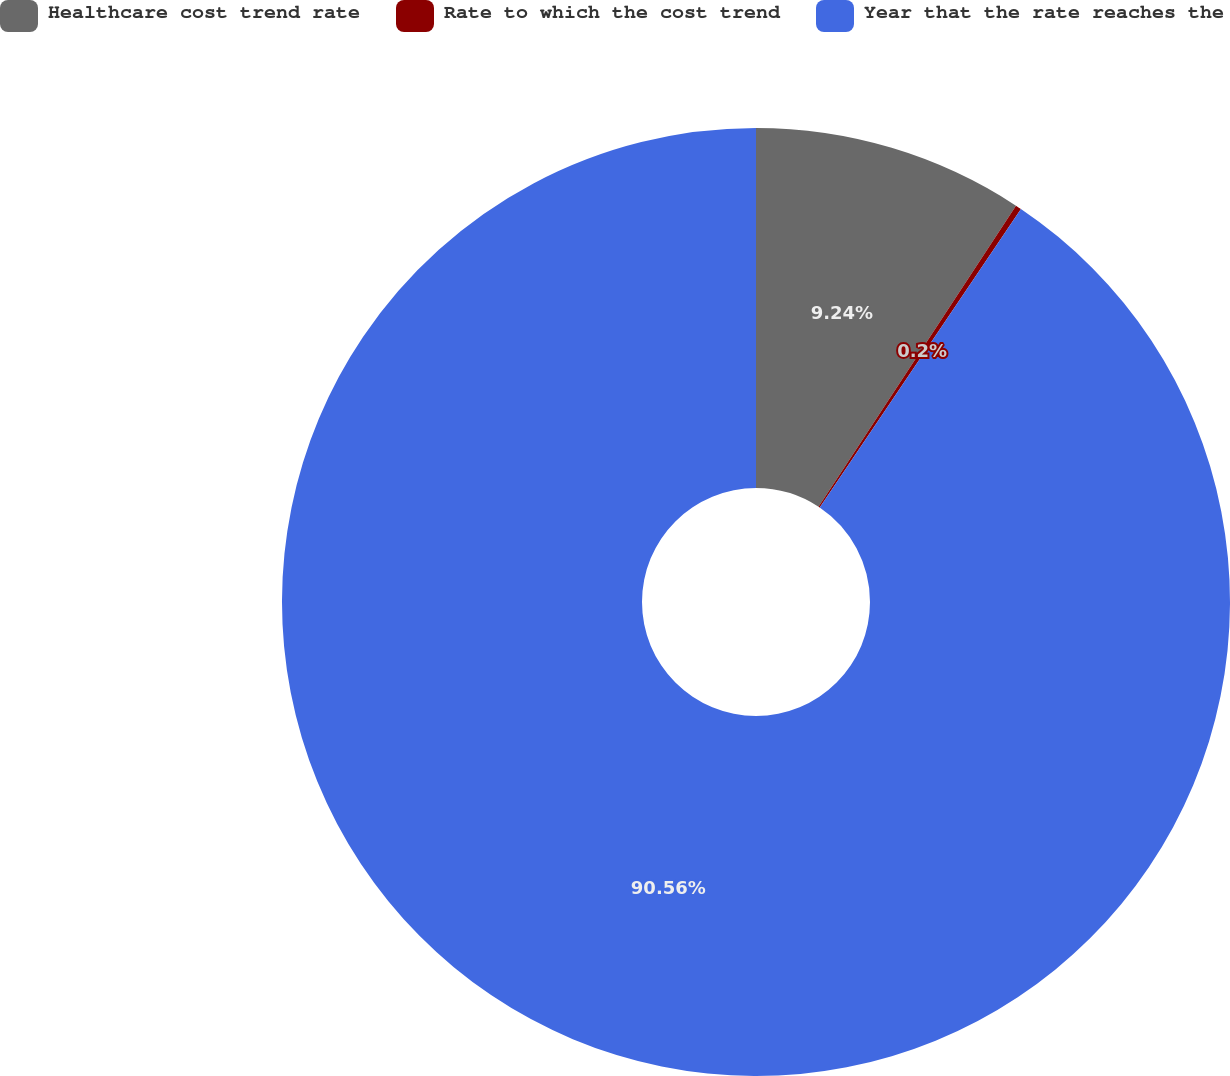Convert chart to OTSL. <chart><loc_0><loc_0><loc_500><loc_500><pie_chart><fcel>Healthcare cost trend rate<fcel>Rate to which the cost trend<fcel>Year that the rate reaches the<nl><fcel>9.24%<fcel>0.2%<fcel>90.56%<nl></chart> 